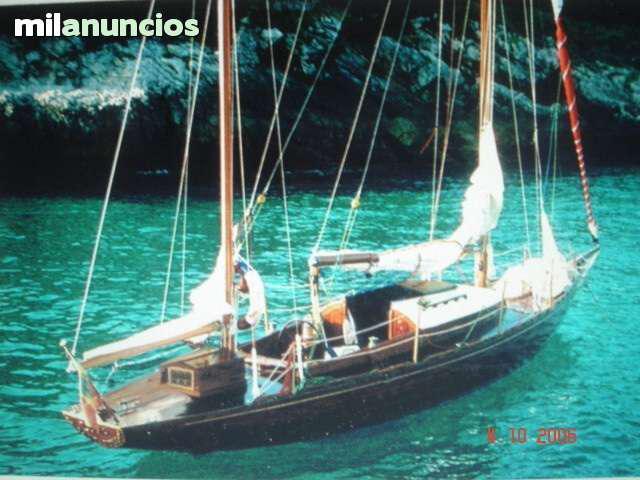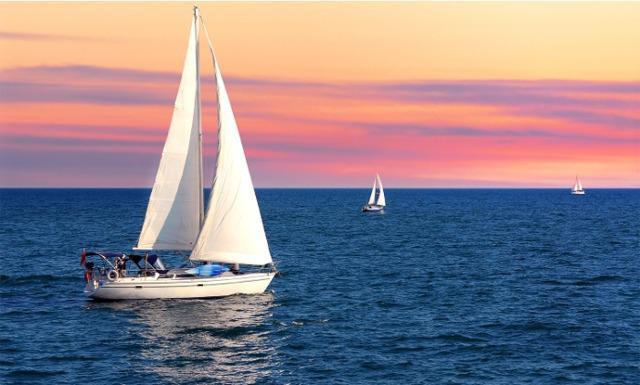The first image is the image on the left, the second image is the image on the right. Evaluate the accuracy of this statement regarding the images: "There is one sailboat without the sails unfurled.". Is it true? Answer yes or no. Yes. 